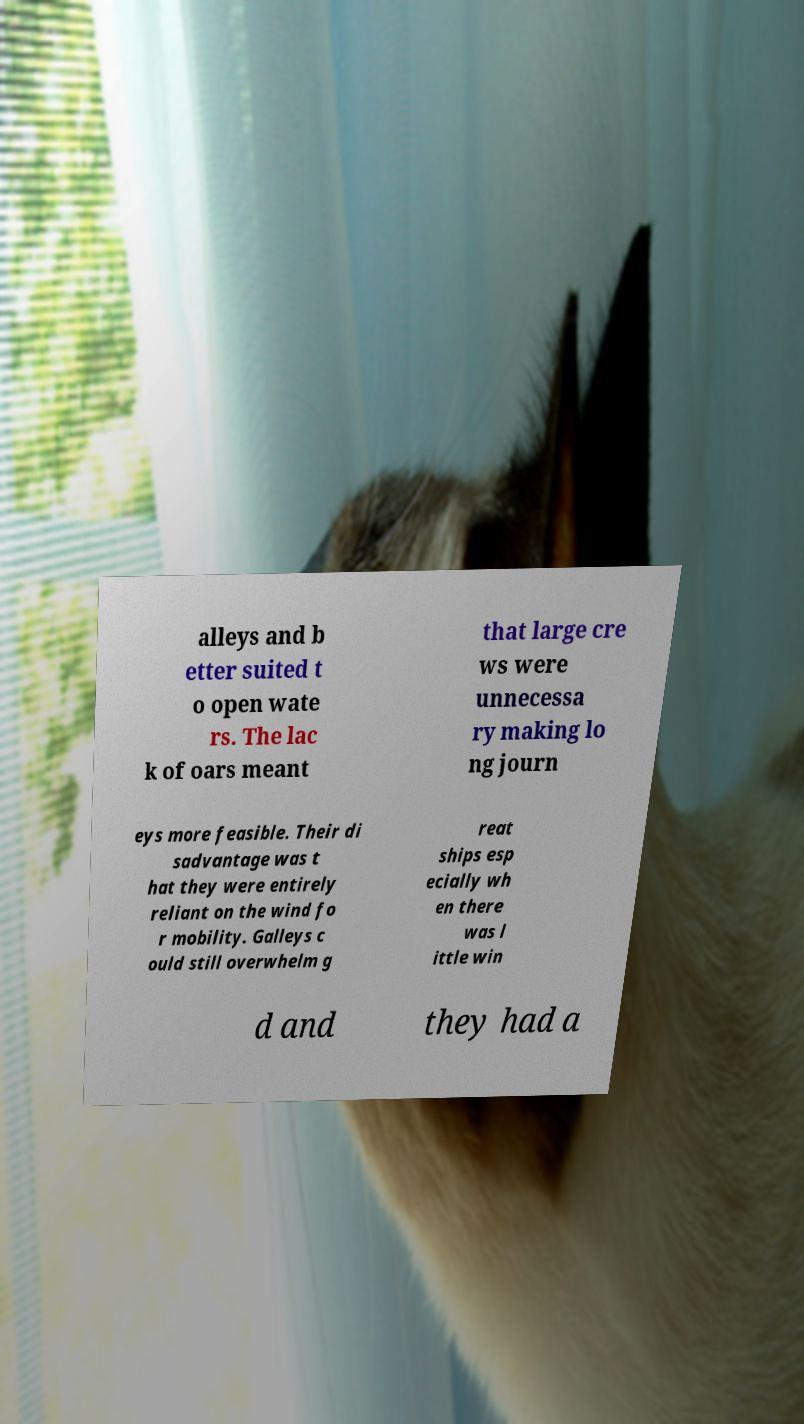Could you assist in decoding the text presented in this image and type it out clearly? alleys and b etter suited t o open wate rs. The lac k of oars meant that large cre ws were unnecessa ry making lo ng journ eys more feasible. Their di sadvantage was t hat they were entirely reliant on the wind fo r mobility. Galleys c ould still overwhelm g reat ships esp ecially wh en there was l ittle win d and they had a 